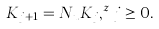<formula> <loc_0><loc_0><loc_500><loc_500>K _ { j + 1 } = N _ { u } K _ { j } , ^ { z } j \geq 0 .</formula> 